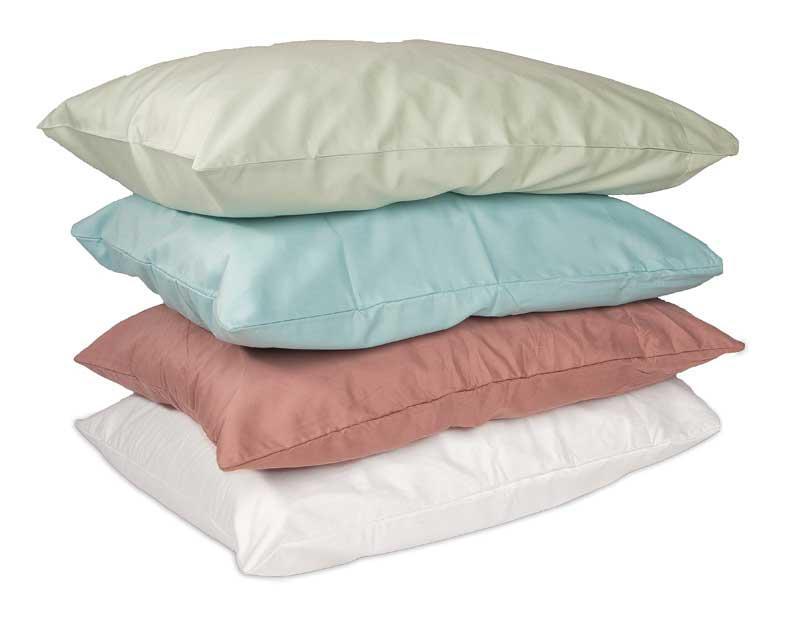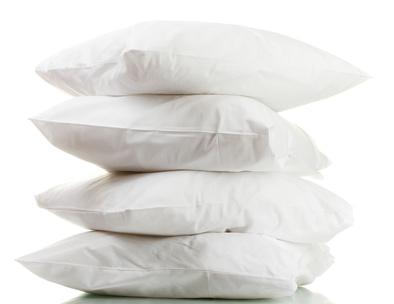The first image is the image on the left, the second image is the image on the right. For the images displayed, is the sentence "The right image contains a vertical stack of at least four pillows." factually correct? Answer yes or no. Yes. 